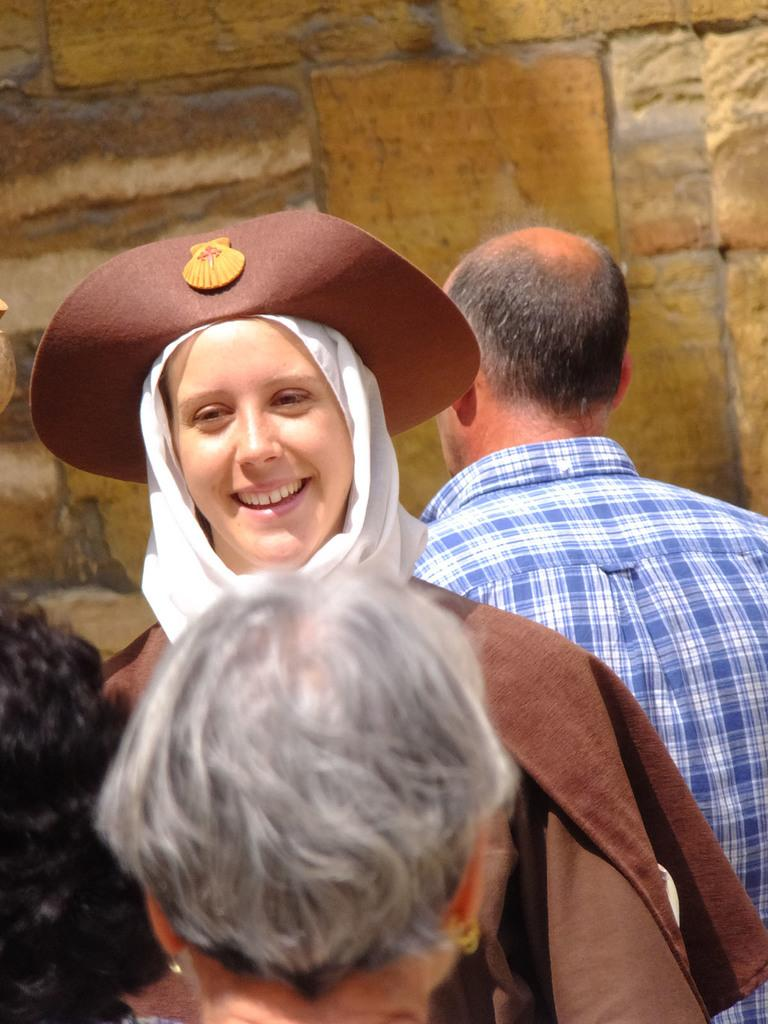How many people are in the image? There are people in the image. Can you describe the expression of one of the people? One of the people is smiling. What can be said about the woman in the image? There is a woman in the image, and she is wearing a hat. What is the color of the woman's dress? The woman's dress is brown in color. What is visible in the background of the image? There is a wall in the background of the image. What type of disease is the woman in the image suffering from? There is no indication in the image that the woman is suffering from any disease. Can you tell me how many examples of calculators are visible in the image? There are no calculators present in the image. 